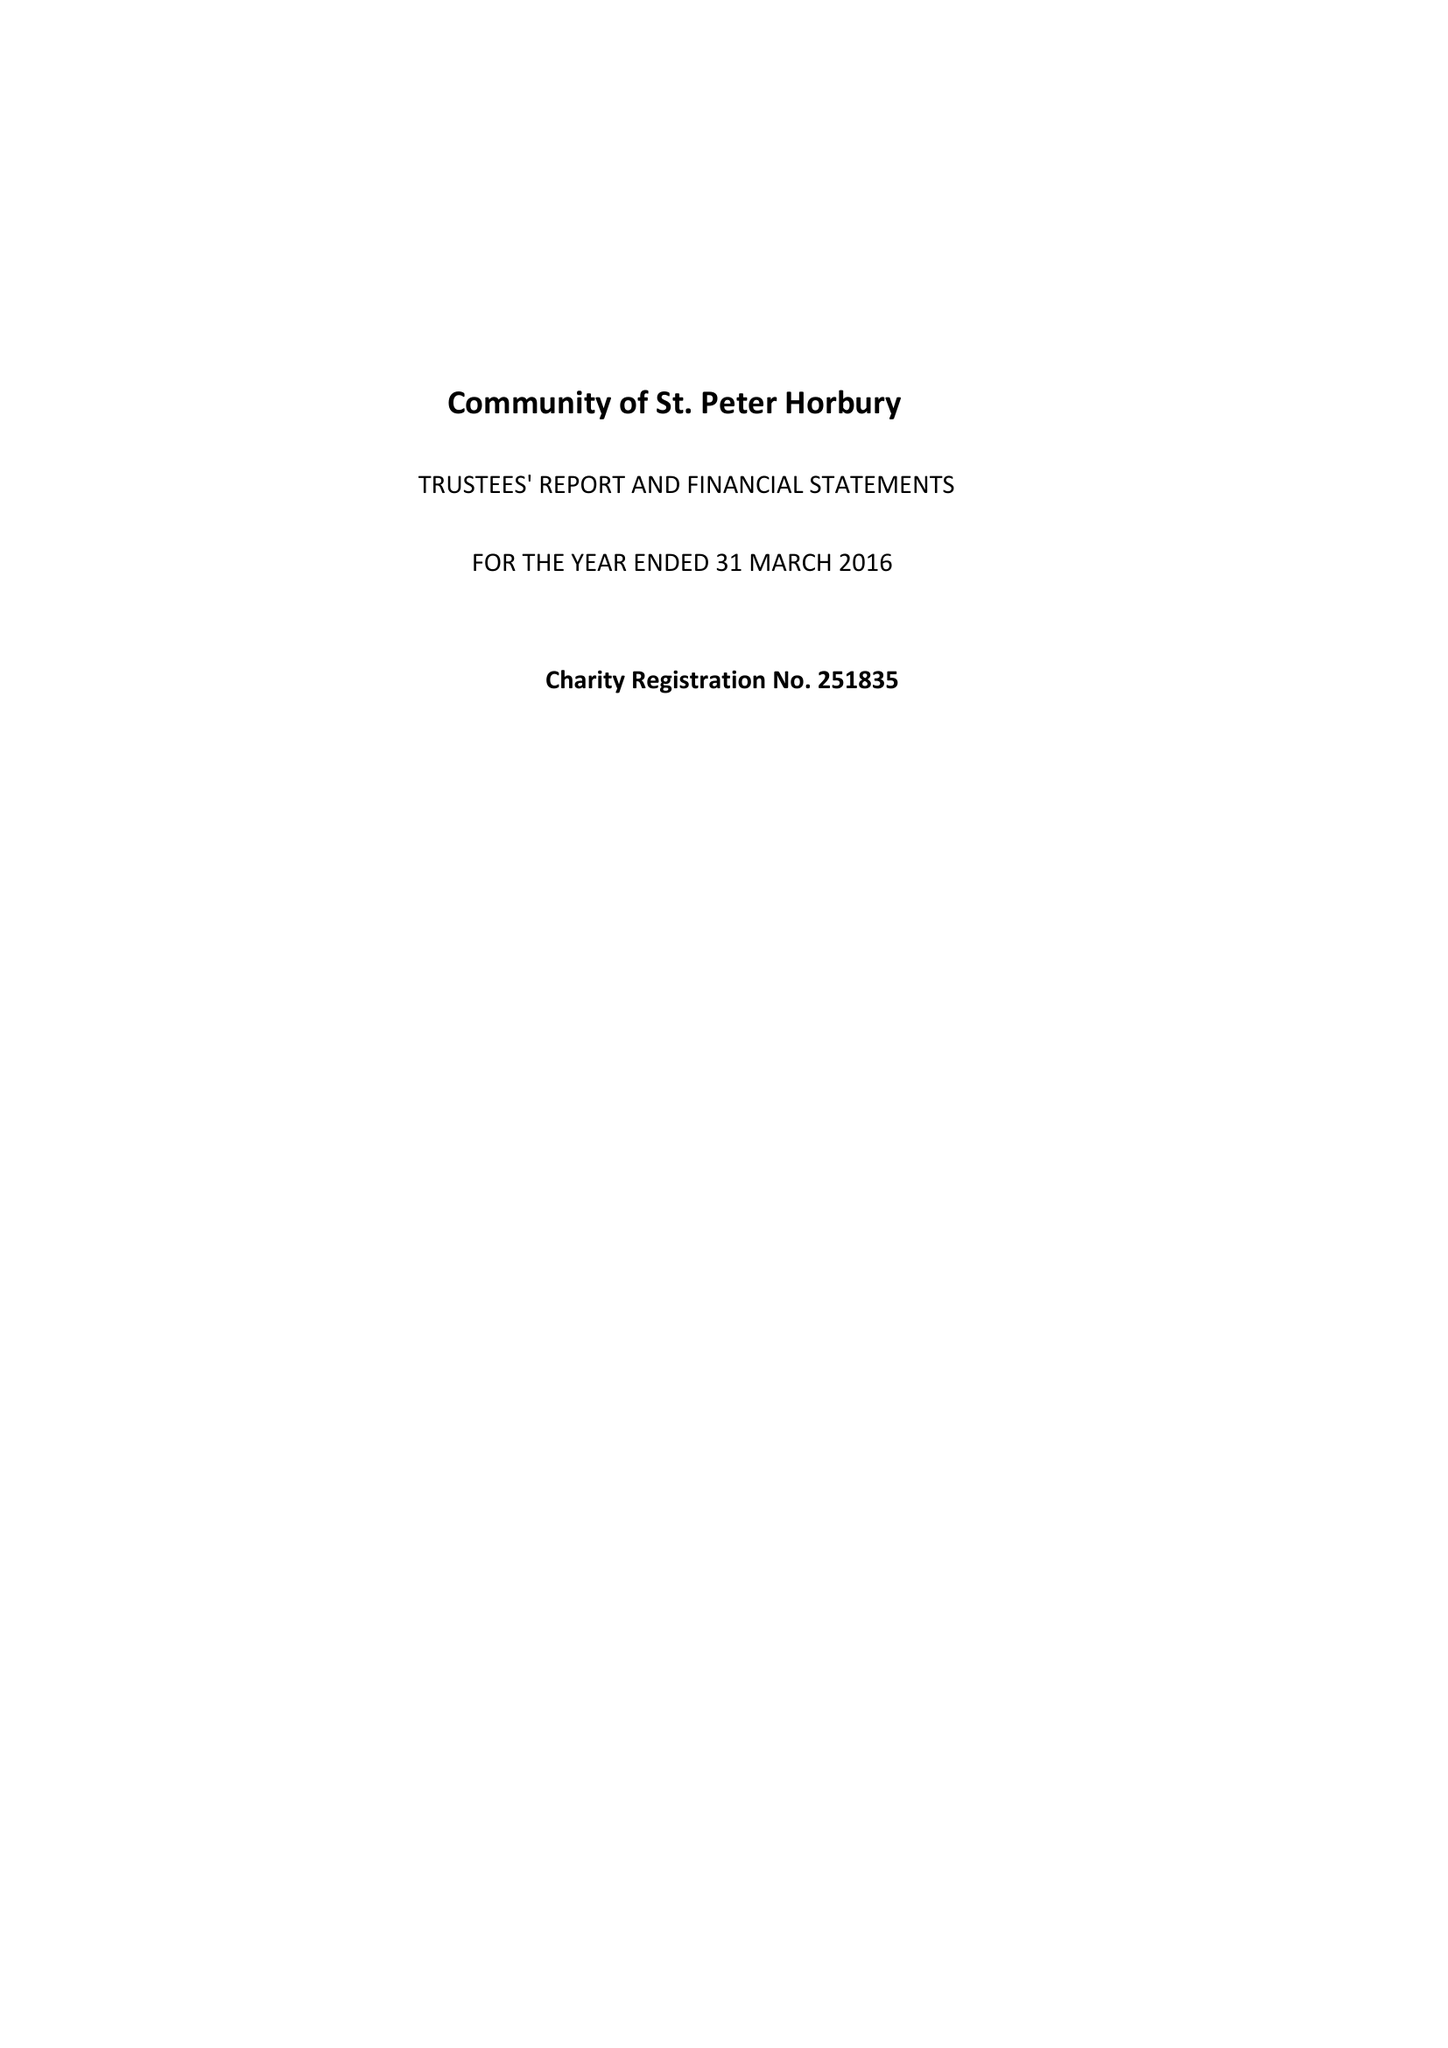What is the value for the charity_number?
Answer the question using a single word or phrase. 251835 